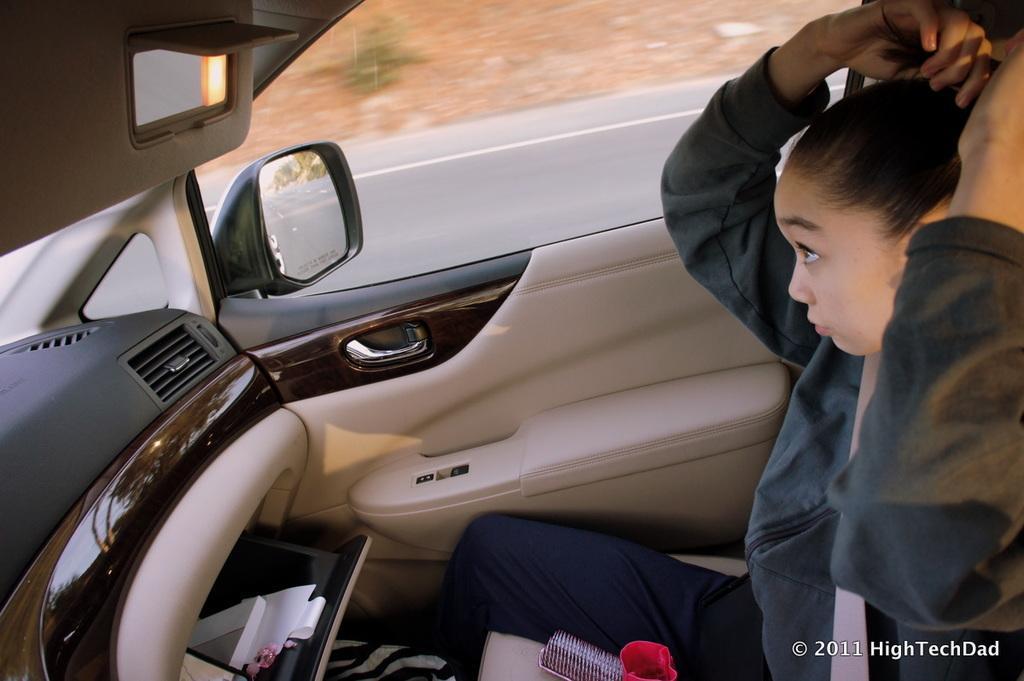In one or two sentences, can you explain what this image depicts? The picture is clicked in the car, in the car there is a woman sitting. In the car there are comb, papers and other objects. At the top there is a side mirror. 